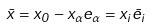Convert formula to latex. <formula><loc_0><loc_0><loc_500><loc_500>\bar { x } = x _ { 0 } - x _ { \alpha } e _ { \alpha } = x _ { i } \bar { e } _ { i }</formula> 